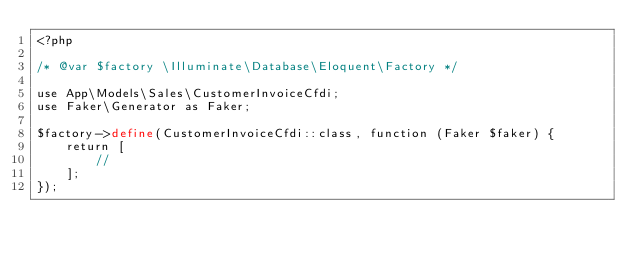Convert code to text. <code><loc_0><loc_0><loc_500><loc_500><_PHP_><?php

/* @var $factory \Illuminate\Database\Eloquent\Factory */

use App\Models\Sales\CustomerInvoiceCfdi;
use Faker\Generator as Faker;

$factory->define(CustomerInvoiceCfdi::class, function (Faker $faker) {
    return [
        //
    ];
});
</code> 